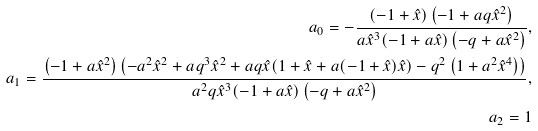<formula> <loc_0><loc_0><loc_500><loc_500>a _ { 0 } = - \frac { ( - 1 + \hat { x } ) \left ( { - } 1 + a q \hat { x } ^ { 2 } \right ) } { a \hat { x } ^ { 3 } ( - 1 + a \hat { x } ) \left ( { - } q + a \hat { x } ^ { 2 } \right ) } , \\ a _ { 1 } = \frac { \left ( { - } 1 + a \hat { x } ^ { 2 } \right ) \left ( { - } a ^ { 2 } \hat { x } ^ { 2 } + a q ^ { 3 } \hat { x } ^ { 2 } + a q \hat { x } ( 1 + \hat { x } + a ( - 1 + \hat { x } ) \hat { x } ) - q ^ { 2 } \left ( 1 + a ^ { 2 } \hat { x } ^ { 4 } \right ) \right ) } { a ^ { 2 } q \hat { x } ^ { 3 } ( - 1 + a \hat { x } ) \left ( { - } q + a \hat { x } ^ { 2 } \right ) } , \\ a _ { 2 } = 1</formula> 